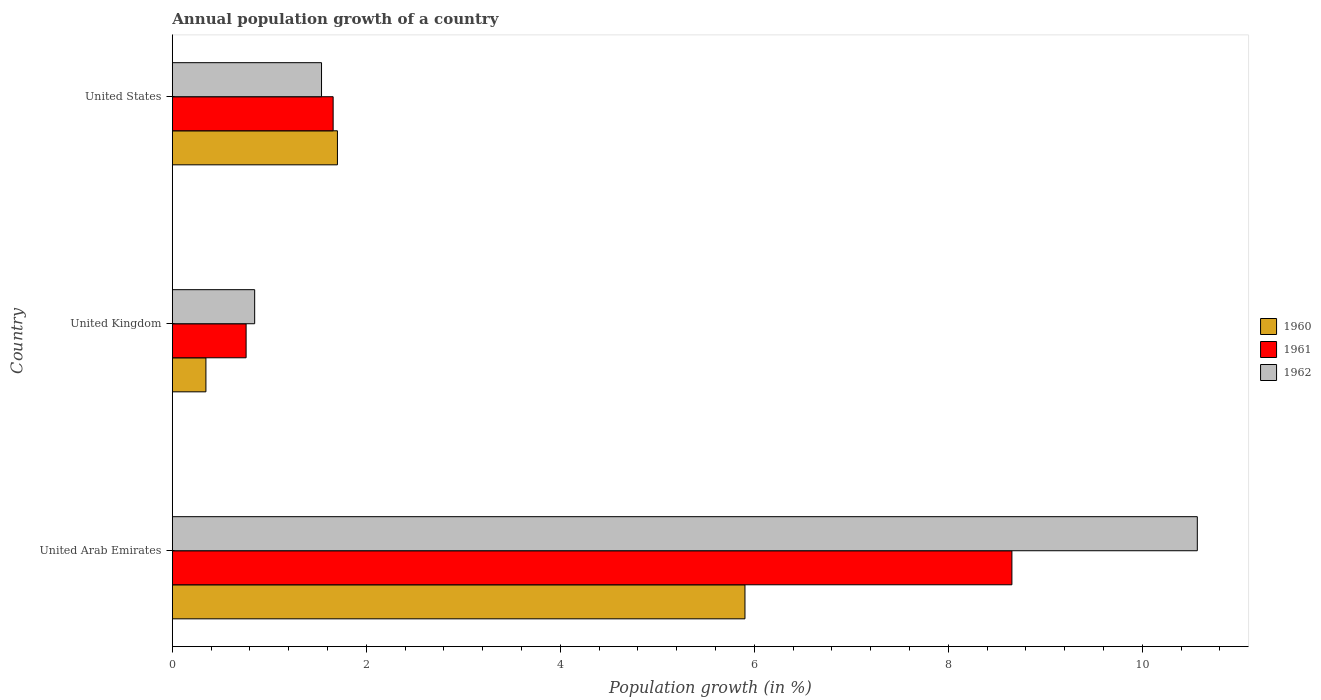How many different coloured bars are there?
Your answer should be compact. 3. How many groups of bars are there?
Your response must be concise. 3. Are the number of bars per tick equal to the number of legend labels?
Your response must be concise. Yes. How many bars are there on the 2nd tick from the top?
Ensure brevity in your answer.  3. How many bars are there on the 1st tick from the bottom?
Ensure brevity in your answer.  3. What is the label of the 1st group of bars from the top?
Offer a very short reply. United States. What is the annual population growth in 1961 in United Arab Emirates?
Make the answer very short. 8.66. Across all countries, what is the maximum annual population growth in 1962?
Keep it short and to the point. 10.57. Across all countries, what is the minimum annual population growth in 1962?
Your answer should be compact. 0.85. In which country was the annual population growth in 1962 maximum?
Give a very brief answer. United Arab Emirates. In which country was the annual population growth in 1960 minimum?
Keep it short and to the point. United Kingdom. What is the total annual population growth in 1961 in the graph?
Offer a terse response. 11.07. What is the difference between the annual population growth in 1960 in United Kingdom and that in United States?
Your answer should be very brief. -1.36. What is the difference between the annual population growth in 1962 in United Kingdom and the annual population growth in 1961 in United Arab Emirates?
Provide a succinct answer. -7.81. What is the average annual population growth in 1960 per country?
Provide a short and direct response. 2.65. What is the difference between the annual population growth in 1960 and annual population growth in 1961 in United Kingdom?
Offer a terse response. -0.41. What is the ratio of the annual population growth in 1962 in United Arab Emirates to that in United Kingdom?
Keep it short and to the point. 12.45. Is the annual population growth in 1961 in United Kingdom less than that in United States?
Keep it short and to the point. Yes. What is the difference between the highest and the second highest annual population growth in 1962?
Provide a short and direct response. 9.03. What is the difference between the highest and the lowest annual population growth in 1960?
Make the answer very short. 5.56. Is it the case that in every country, the sum of the annual population growth in 1961 and annual population growth in 1960 is greater than the annual population growth in 1962?
Your answer should be compact. Yes. How many countries are there in the graph?
Keep it short and to the point. 3. Are the values on the major ticks of X-axis written in scientific E-notation?
Give a very brief answer. No. Does the graph contain any zero values?
Make the answer very short. No. Does the graph contain grids?
Provide a short and direct response. No. What is the title of the graph?
Your answer should be compact. Annual population growth of a country. What is the label or title of the X-axis?
Provide a succinct answer. Population growth (in %). What is the label or title of the Y-axis?
Offer a terse response. Country. What is the Population growth (in %) in 1960 in United Arab Emirates?
Your response must be concise. 5.9. What is the Population growth (in %) of 1961 in United Arab Emirates?
Keep it short and to the point. 8.66. What is the Population growth (in %) in 1962 in United Arab Emirates?
Keep it short and to the point. 10.57. What is the Population growth (in %) in 1960 in United Kingdom?
Give a very brief answer. 0.35. What is the Population growth (in %) in 1961 in United Kingdom?
Provide a succinct answer. 0.76. What is the Population growth (in %) in 1962 in United Kingdom?
Make the answer very short. 0.85. What is the Population growth (in %) in 1960 in United States?
Offer a terse response. 1.7. What is the Population growth (in %) of 1961 in United States?
Your answer should be very brief. 1.66. What is the Population growth (in %) in 1962 in United States?
Your response must be concise. 1.54. Across all countries, what is the maximum Population growth (in %) in 1960?
Ensure brevity in your answer.  5.9. Across all countries, what is the maximum Population growth (in %) in 1961?
Keep it short and to the point. 8.66. Across all countries, what is the maximum Population growth (in %) of 1962?
Your response must be concise. 10.57. Across all countries, what is the minimum Population growth (in %) in 1960?
Your response must be concise. 0.35. Across all countries, what is the minimum Population growth (in %) of 1961?
Give a very brief answer. 0.76. Across all countries, what is the minimum Population growth (in %) in 1962?
Your answer should be very brief. 0.85. What is the total Population growth (in %) in 1960 in the graph?
Make the answer very short. 7.95. What is the total Population growth (in %) of 1961 in the graph?
Offer a terse response. 11.07. What is the total Population growth (in %) in 1962 in the graph?
Ensure brevity in your answer.  12.95. What is the difference between the Population growth (in %) of 1960 in United Arab Emirates and that in United Kingdom?
Your response must be concise. 5.56. What is the difference between the Population growth (in %) in 1961 in United Arab Emirates and that in United Kingdom?
Your answer should be compact. 7.89. What is the difference between the Population growth (in %) of 1962 in United Arab Emirates and that in United Kingdom?
Provide a succinct answer. 9.72. What is the difference between the Population growth (in %) of 1960 in United Arab Emirates and that in United States?
Give a very brief answer. 4.2. What is the difference between the Population growth (in %) of 1961 in United Arab Emirates and that in United States?
Give a very brief answer. 7. What is the difference between the Population growth (in %) in 1962 in United Arab Emirates and that in United States?
Provide a short and direct response. 9.03. What is the difference between the Population growth (in %) in 1960 in United Kingdom and that in United States?
Ensure brevity in your answer.  -1.36. What is the difference between the Population growth (in %) of 1961 in United Kingdom and that in United States?
Provide a succinct answer. -0.9. What is the difference between the Population growth (in %) of 1962 in United Kingdom and that in United States?
Give a very brief answer. -0.69. What is the difference between the Population growth (in %) of 1960 in United Arab Emirates and the Population growth (in %) of 1961 in United Kingdom?
Offer a very short reply. 5.14. What is the difference between the Population growth (in %) of 1960 in United Arab Emirates and the Population growth (in %) of 1962 in United Kingdom?
Keep it short and to the point. 5.05. What is the difference between the Population growth (in %) of 1961 in United Arab Emirates and the Population growth (in %) of 1962 in United Kingdom?
Give a very brief answer. 7.81. What is the difference between the Population growth (in %) of 1960 in United Arab Emirates and the Population growth (in %) of 1961 in United States?
Offer a terse response. 4.25. What is the difference between the Population growth (in %) of 1960 in United Arab Emirates and the Population growth (in %) of 1962 in United States?
Make the answer very short. 4.37. What is the difference between the Population growth (in %) of 1961 in United Arab Emirates and the Population growth (in %) of 1962 in United States?
Offer a very short reply. 7.12. What is the difference between the Population growth (in %) of 1960 in United Kingdom and the Population growth (in %) of 1961 in United States?
Make the answer very short. -1.31. What is the difference between the Population growth (in %) in 1960 in United Kingdom and the Population growth (in %) in 1962 in United States?
Keep it short and to the point. -1.19. What is the difference between the Population growth (in %) of 1961 in United Kingdom and the Population growth (in %) of 1962 in United States?
Your answer should be very brief. -0.78. What is the average Population growth (in %) in 1960 per country?
Your response must be concise. 2.65. What is the average Population growth (in %) of 1961 per country?
Keep it short and to the point. 3.69. What is the average Population growth (in %) of 1962 per country?
Your answer should be very brief. 4.32. What is the difference between the Population growth (in %) in 1960 and Population growth (in %) in 1961 in United Arab Emirates?
Keep it short and to the point. -2.75. What is the difference between the Population growth (in %) of 1960 and Population growth (in %) of 1962 in United Arab Emirates?
Ensure brevity in your answer.  -4.66. What is the difference between the Population growth (in %) in 1961 and Population growth (in %) in 1962 in United Arab Emirates?
Provide a succinct answer. -1.91. What is the difference between the Population growth (in %) of 1960 and Population growth (in %) of 1961 in United Kingdom?
Your answer should be compact. -0.41. What is the difference between the Population growth (in %) of 1960 and Population growth (in %) of 1962 in United Kingdom?
Provide a succinct answer. -0.5. What is the difference between the Population growth (in %) in 1961 and Population growth (in %) in 1962 in United Kingdom?
Keep it short and to the point. -0.09. What is the difference between the Population growth (in %) of 1960 and Population growth (in %) of 1961 in United States?
Your response must be concise. 0.04. What is the difference between the Population growth (in %) of 1960 and Population growth (in %) of 1962 in United States?
Give a very brief answer. 0.16. What is the difference between the Population growth (in %) in 1961 and Population growth (in %) in 1962 in United States?
Keep it short and to the point. 0.12. What is the ratio of the Population growth (in %) of 1960 in United Arab Emirates to that in United Kingdom?
Ensure brevity in your answer.  17.06. What is the ratio of the Population growth (in %) in 1961 in United Arab Emirates to that in United Kingdom?
Your answer should be very brief. 11.38. What is the ratio of the Population growth (in %) of 1962 in United Arab Emirates to that in United Kingdom?
Ensure brevity in your answer.  12.45. What is the ratio of the Population growth (in %) of 1960 in United Arab Emirates to that in United States?
Your response must be concise. 3.47. What is the ratio of the Population growth (in %) of 1961 in United Arab Emirates to that in United States?
Keep it short and to the point. 5.22. What is the ratio of the Population growth (in %) of 1962 in United Arab Emirates to that in United States?
Your response must be concise. 6.87. What is the ratio of the Population growth (in %) in 1960 in United Kingdom to that in United States?
Provide a short and direct response. 0.2. What is the ratio of the Population growth (in %) in 1961 in United Kingdom to that in United States?
Provide a short and direct response. 0.46. What is the ratio of the Population growth (in %) of 1962 in United Kingdom to that in United States?
Your answer should be compact. 0.55. What is the difference between the highest and the second highest Population growth (in %) of 1960?
Your answer should be compact. 4.2. What is the difference between the highest and the second highest Population growth (in %) in 1961?
Provide a short and direct response. 7. What is the difference between the highest and the second highest Population growth (in %) of 1962?
Offer a very short reply. 9.03. What is the difference between the highest and the lowest Population growth (in %) in 1960?
Give a very brief answer. 5.56. What is the difference between the highest and the lowest Population growth (in %) in 1961?
Provide a succinct answer. 7.89. What is the difference between the highest and the lowest Population growth (in %) in 1962?
Offer a terse response. 9.72. 